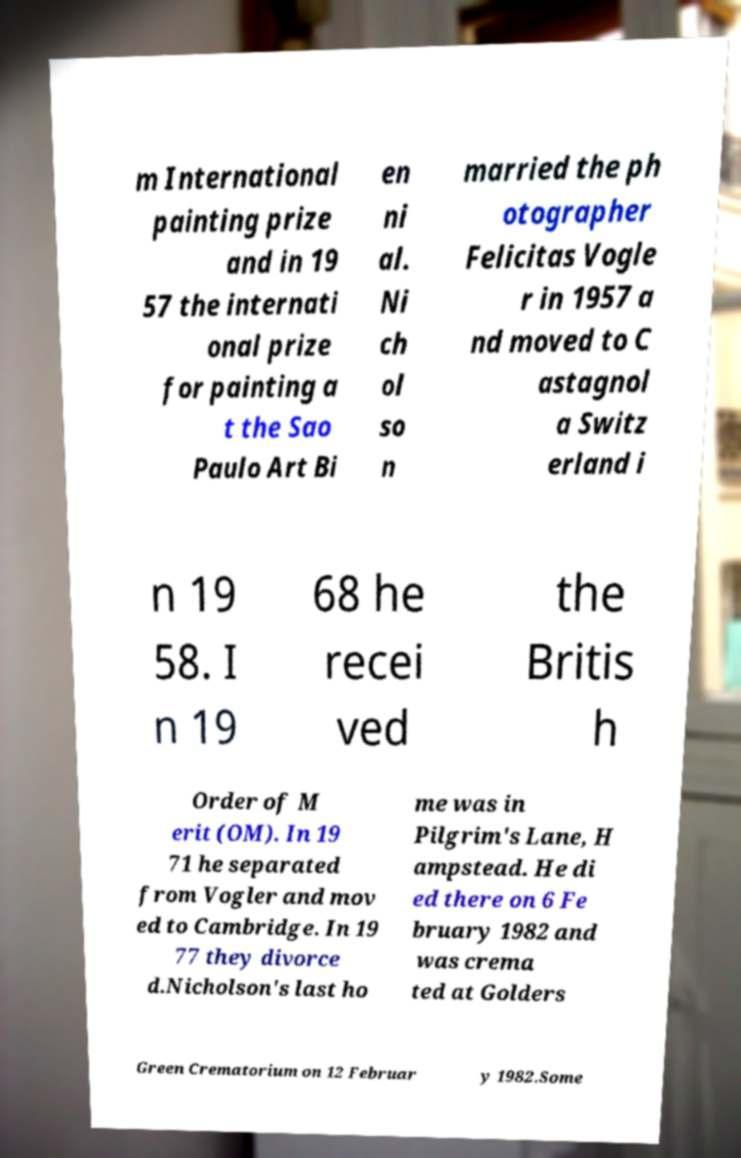For documentation purposes, I need the text within this image transcribed. Could you provide that? m International painting prize and in 19 57 the internati onal prize for painting a t the Sao Paulo Art Bi en ni al. Ni ch ol so n married the ph otographer Felicitas Vogle r in 1957 a nd moved to C astagnol a Switz erland i n 19 58. I n 19 68 he recei ved the Britis h Order of M erit (OM). In 19 71 he separated from Vogler and mov ed to Cambridge. In 19 77 they divorce d.Nicholson's last ho me was in Pilgrim's Lane, H ampstead. He di ed there on 6 Fe bruary 1982 and was crema ted at Golders Green Crematorium on 12 Februar y 1982.Some 